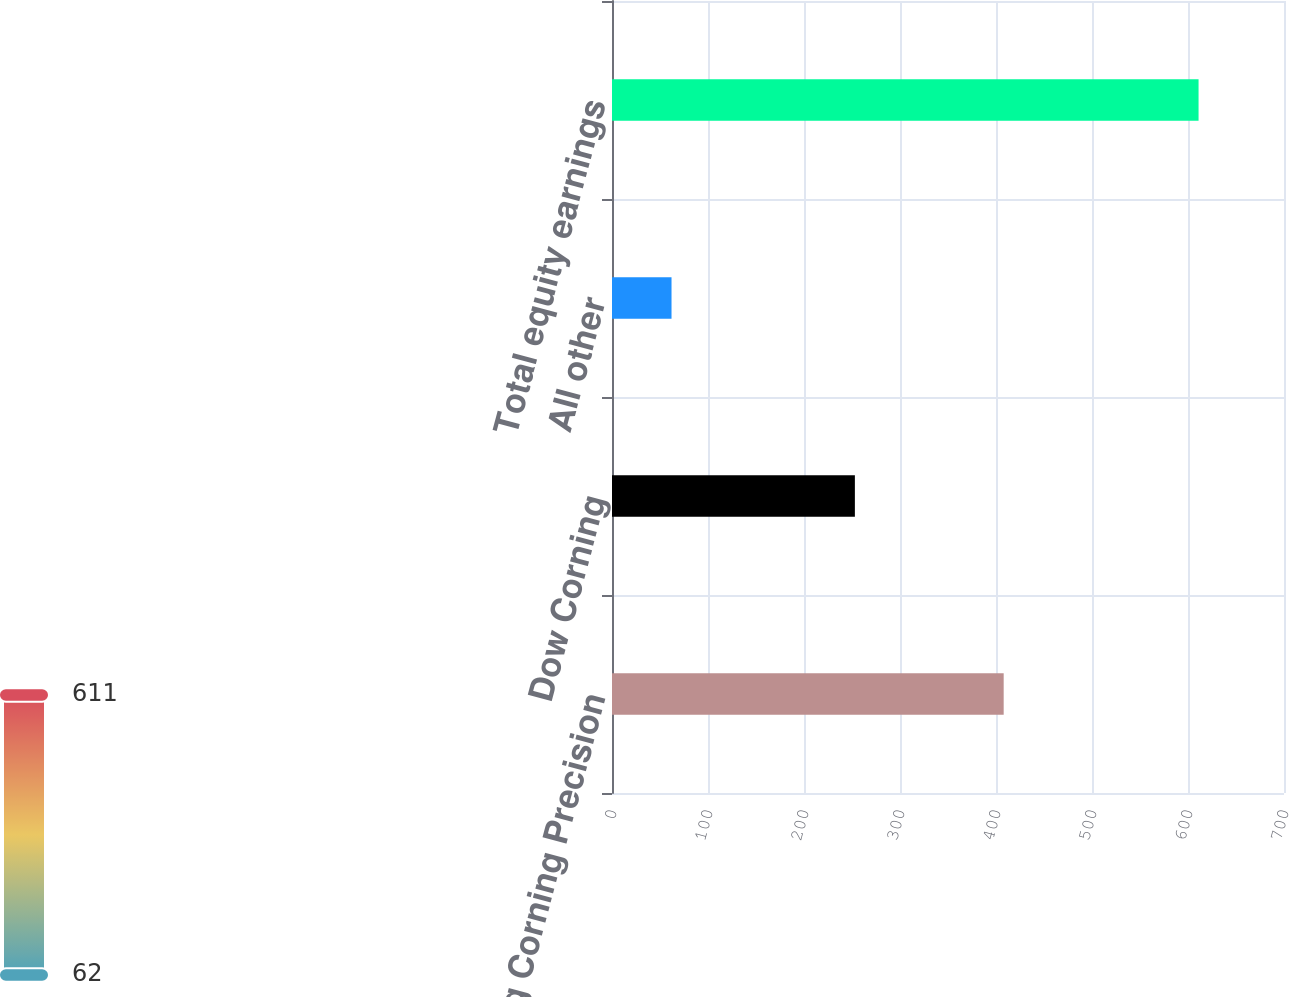<chart> <loc_0><loc_0><loc_500><loc_500><bar_chart><fcel>Samsung Corning Precision<fcel>Dow Corning<fcel>All other<fcel>Total equity earnings<nl><fcel>408<fcel>253<fcel>62<fcel>611<nl></chart> 